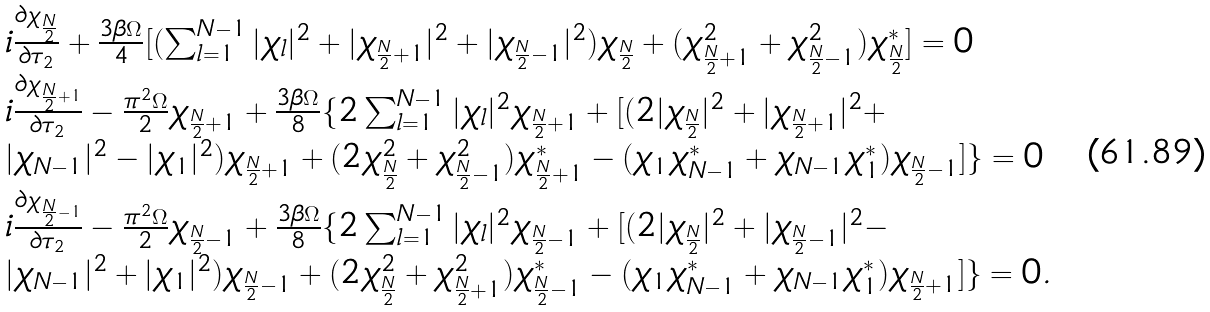<formula> <loc_0><loc_0><loc_500><loc_500>\begin{array} { l } { i \frac { \partial \chi _ { \frac { N } { 2 } } } { \partial \tau _ { 2 } } + \frac { 3 \beta \Omega } { 4 } [ ( \sum _ { l = 1 } ^ { N - 1 } | \chi _ { l } | ^ { 2 } + | \chi _ { \frac { N } { 2 } + 1 } | ^ { 2 } + | \chi _ { \frac { N } { 2 } - 1 } | ^ { 2 } ) \chi _ { \frac { N } { 2 } } + ( \chi _ { \frac { N } { 2 } + 1 } ^ { 2 } + \chi _ { \frac { N } { 2 } - 1 } ^ { 2 } ) \chi _ { \frac { N } { 2 } } ^ { * } ] = 0 } \\ { i \frac { \partial \chi _ { \frac { N } { 2 } + 1 } } { \partial \tau _ { 2 } } - \frac { \pi ^ { 2 } \Omega } { 2 } \chi _ { \frac { N } { 2 } + 1 } + \frac { 3 \beta \Omega } { 8 } \{ 2 \sum _ { l = 1 } ^ { N - 1 } | \chi _ { l } | ^ { 2 } \chi _ { \frac { N } { 2 } + 1 } + [ ( 2 | \chi _ { \frac { N } { 2 } } | ^ { 2 } + | \chi _ { \frac { N } { 2 } + 1 } | ^ { 2 } + } \\ { | \chi _ { N - 1 } | ^ { 2 } - | \chi _ { 1 } | ^ { 2 } ) \chi _ { \frac { N } { 2 } + 1 } + ( 2 \chi _ { \frac { N } { 2 } } ^ { 2 } + \chi _ { \frac { N } { 2 } - 1 } ^ { 2 } ) \chi _ { \frac { N } { 2 } + 1 } ^ { * } - ( \chi _ { 1 } \chi _ { N - 1 } ^ { * } + \chi _ { N - 1 } \chi _ { 1 } ^ { * } ) \chi _ { \frac { N } { 2 } - 1 } ] \} = 0 } \\ { i \frac { \partial \chi _ { \frac { N } { 2 } - 1 } } { \partial \tau _ { 2 } } - \frac { \pi ^ { 2 } \Omega } { 2 } \chi _ { \frac { N } { 2 } - 1 } + \frac { 3 \beta \Omega } { 8 } \{ 2 \sum _ { l = 1 } ^ { N - 1 } | \chi _ { l } | ^ { 2 } \chi _ { \frac { N } { 2 } - 1 } + [ ( 2 | \chi _ { \frac { N } { 2 } } | ^ { 2 } + | \chi _ { \frac { N } { 2 } - 1 } | ^ { 2 } - } \\ { | \chi _ { N - 1 } | ^ { 2 } + | \chi _ { 1 } | ^ { 2 } ) \chi _ { \frac { N } { 2 } - 1 } + ( 2 \chi _ { \frac { N } { 2 } } ^ { 2 } + \chi _ { \frac { N } { 2 } + 1 } ^ { 2 } ) \chi _ { \frac { N } { 2 } - 1 } ^ { * } - ( \chi _ { 1 } \chi _ { N - 1 } ^ { * } + \chi _ { N - 1 } \chi _ { 1 } ^ { * } ) \chi _ { \frac { N } { 2 } + 1 } ] \} = 0 } . \end{array}</formula> 